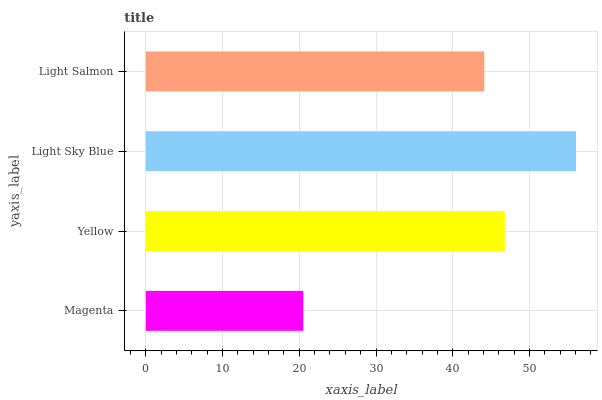Is Magenta the minimum?
Answer yes or no. Yes. Is Light Sky Blue the maximum?
Answer yes or no. Yes. Is Yellow the minimum?
Answer yes or no. No. Is Yellow the maximum?
Answer yes or no. No. Is Yellow greater than Magenta?
Answer yes or no. Yes. Is Magenta less than Yellow?
Answer yes or no. Yes. Is Magenta greater than Yellow?
Answer yes or no. No. Is Yellow less than Magenta?
Answer yes or no. No. Is Yellow the high median?
Answer yes or no. Yes. Is Light Salmon the low median?
Answer yes or no. Yes. Is Light Sky Blue the high median?
Answer yes or no. No. Is Yellow the low median?
Answer yes or no. No. 